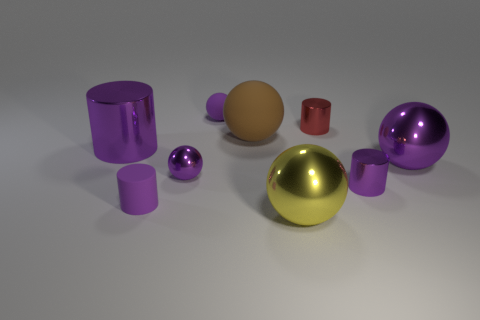The rubber thing that is on the left side of the small shiny sphere has what shape?
Your answer should be compact. Cylinder. How many tiny purple things are the same shape as the large yellow thing?
Keep it short and to the point. 2. Are there the same number of tiny matte balls that are in front of the tiny rubber ball and brown things that are behind the small purple shiny ball?
Your response must be concise. No. Are there any yellow things made of the same material as the big purple ball?
Offer a very short reply. Yes. Are the large purple sphere and the brown object made of the same material?
Provide a succinct answer. No. How many cyan things are tiny rubber things or tiny spheres?
Your answer should be very brief. 0. Are there more small objects that are on the left side of the purple rubber ball than purple rubber cylinders?
Your response must be concise. Yes. Are there any big rubber balls of the same color as the small metal sphere?
Provide a short and direct response. No. The red thing is what size?
Ensure brevity in your answer.  Small. Is the tiny matte cylinder the same color as the big cylinder?
Your answer should be compact. Yes. 